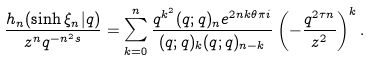Convert formula to latex. <formula><loc_0><loc_0><loc_500><loc_500>\frac { h _ { n } ( \sinh \xi _ { n } | q ) } { z ^ { n } q ^ { - n ^ { 2 } s } } = \sum _ { k = 0 } ^ { n } \frac { q ^ { k ^ { 2 } } ( q ; q ) _ { n } e ^ { 2 n k \theta \pi i } } { ( q ; q ) _ { k } ( q ; q ) _ { n - k } } \left ( - \frac { q ^ { 2 \tau n } } { z ^ { 2 } } \right ) ^ { k } .</formula> 